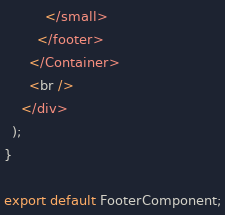<code> <loc_0><loc_0><loc_500><loc_500><_JavaScript_>          </small>
        </footer>
      </Container>
      <br />
    </div>
  );
}

export default FooterComponent;
</code> 